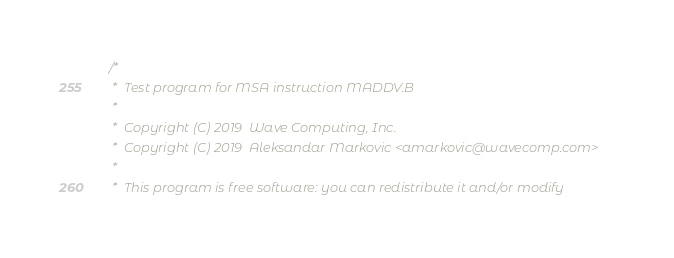<code> <loc_0><loc_0><loc_500><loc_500><_C_>/*
 *  Test program for MSA instruction MADDV.B
 *
 *  Copyright (C) 2019  Wave Computing, Inc.
 *  Copyright (C) 2019  Aleksandar Markovic <amarkovic@wavecomp.com>
 *
 *  This program is free software: you can redistribute it and/or modify</code> 